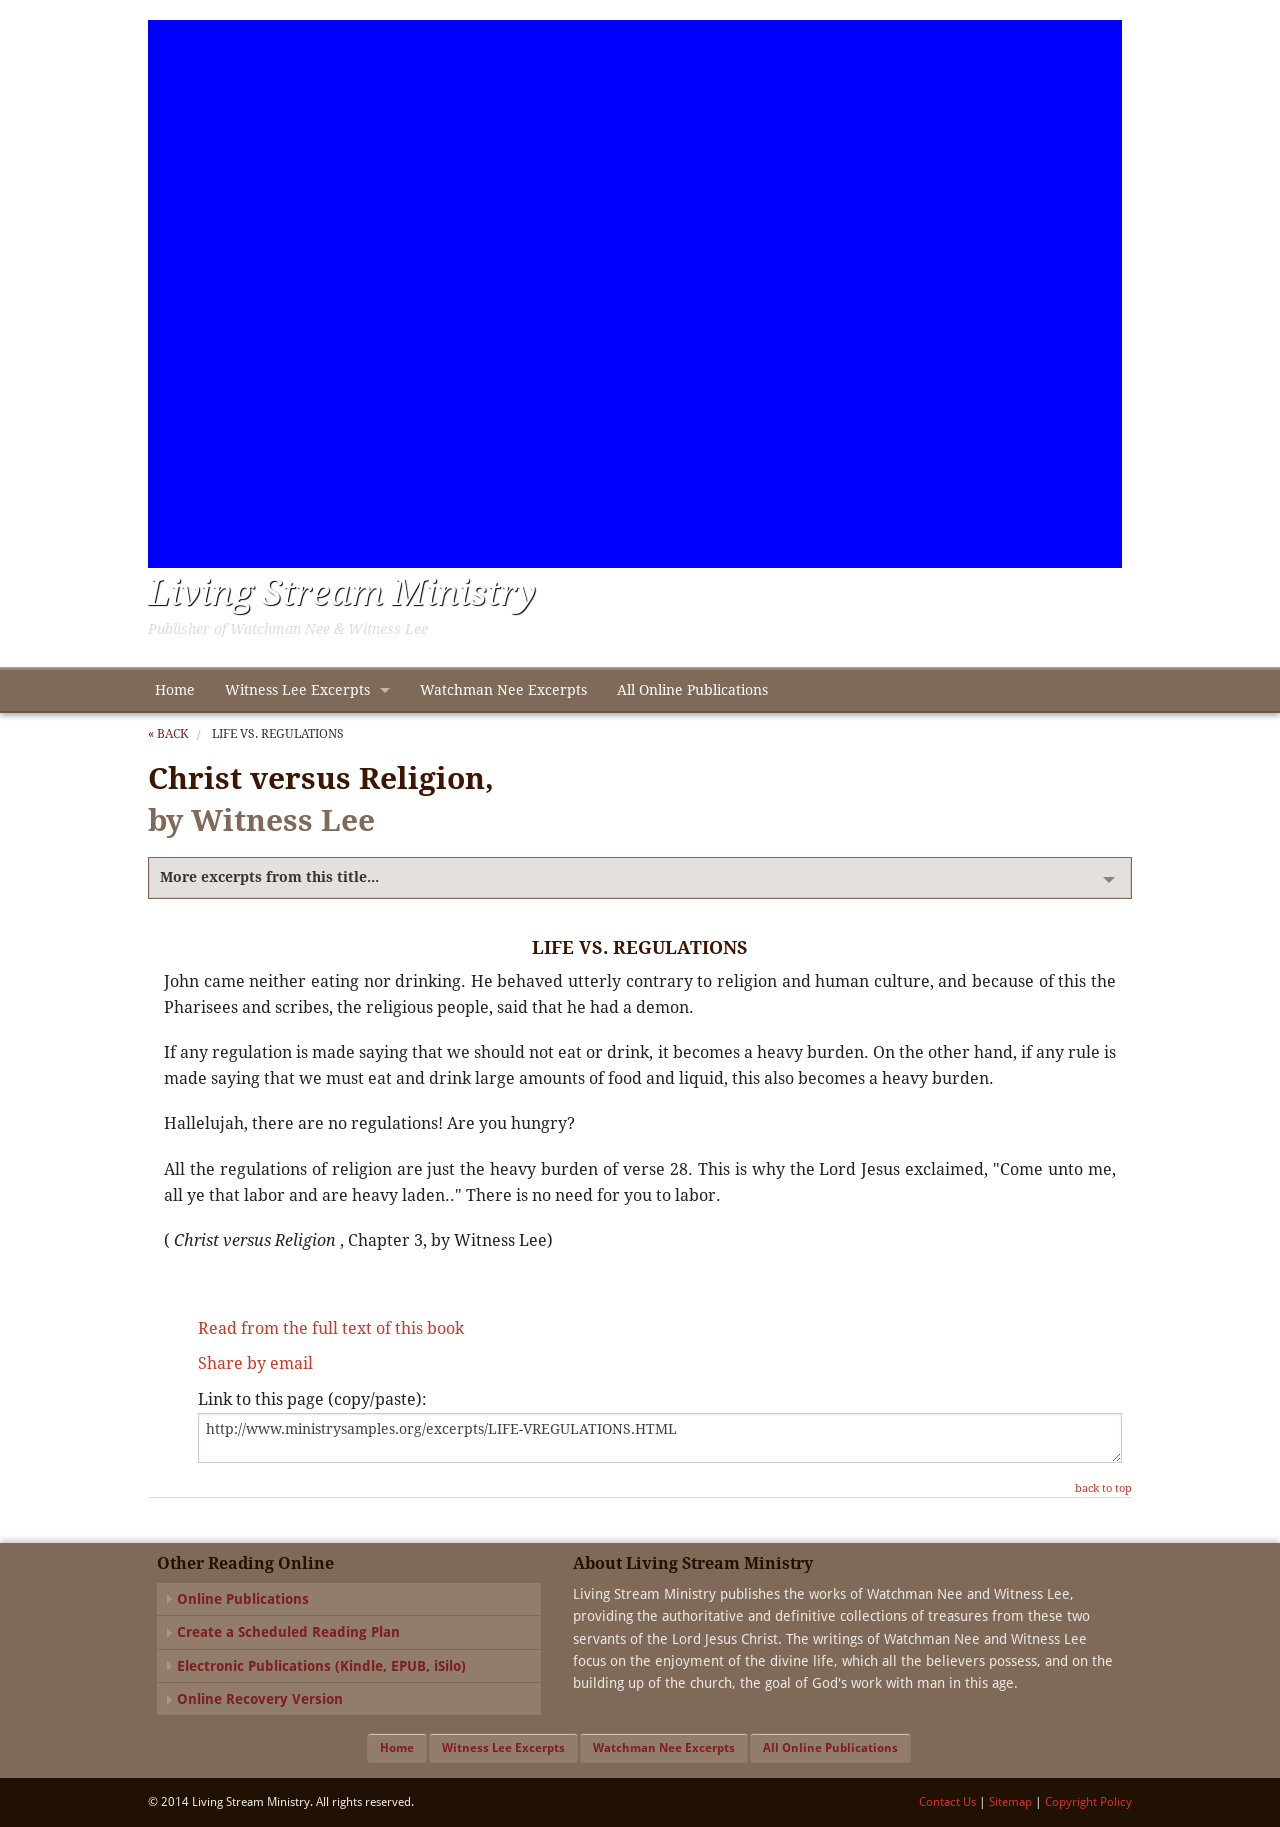What themes are explored in the content displayed in this image? The image shows content related to the contrast between Christ and religious legalism. The themes explored here involve the burden of religious regulations versus the liberating experience offered by Christ, emphasizing spiritual freedom over ritual and tradition. 